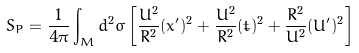<formula> <loc_0><loc_0><loc_500><loc_500>S _ { P } = \frac { 1 } { 4 \pi } \int _ { M } d ^ { 2 } \sigma \left [ \frac { U ^ { 2 } } { R ^ { 2 } } ( x ^ { \prime } ) ^ { 2 } + \frac { U ^ { 2 } } { R ^ { 2 } } ( \dot { t } ) ^ { 2 } + \frac { R ^ { 2 } } { U ^ { 2 } } ( U ^ { \prime } ) ^ { 2 } \right ]</formula> 